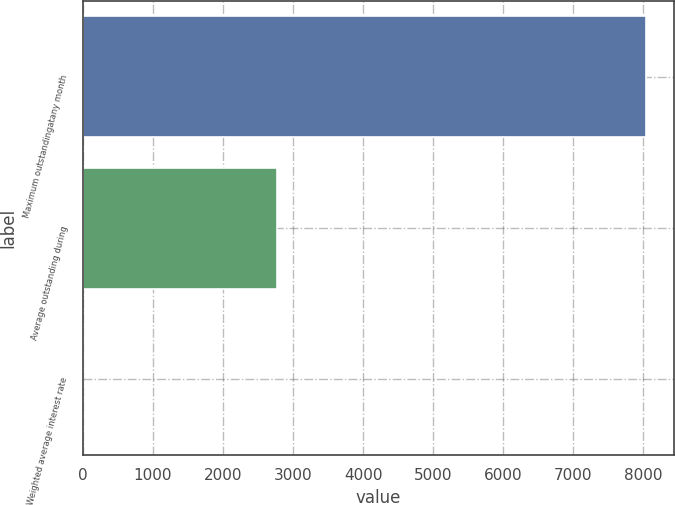Convert chart. <chart><loc_0><loc_0><loc_500><loc_500><bar_chart><fcel>Maximum outstandingatany month<fcel>Average outstanding during<fcel>Weighted average interest rate<nl><fcel>8040<fcel>2777<fcel>5.04<nl></chart> 